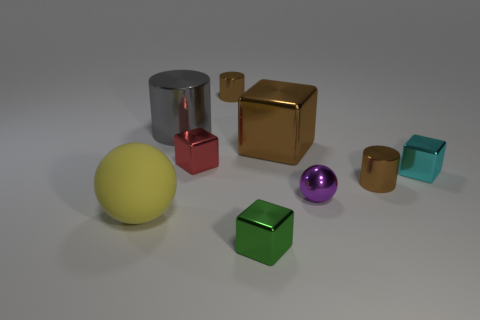Do the cyan thing and the brown thing to the right of the purple metallic sphere have the same size?
Your answer should be compact. Yes. How many things are either purple metallic spheres or cyan cubes?
Your response must be concise. 2. Are there any green things made of the same material as the large gray thing?
Keep it short and to the point. Yes. There is a small thing in front of the small purple sphere on the right side of the small green object; what color is it?
Provide a succinct answer. Green. Is the cyan block the same size as the green metallic block?
Your response must be concise. Yes. What number of spheres are either big gray things or cyan metallic objects?
Your response must be concise. 0. There is a cube that is behind the red block; what number of tiny purple metal things are in front of it?
Make the answer very short. 1. Is the shape of the cyan object the same as the large gray metal thing?
Offer a terse response. No. What size is the red metallic object that is the same shape as the tiny cyan thing?
Give a very brief answer. Small. What is the shape of the object right of the small brown cylinder right of the brown block?
Your response must be concise. Cube. 